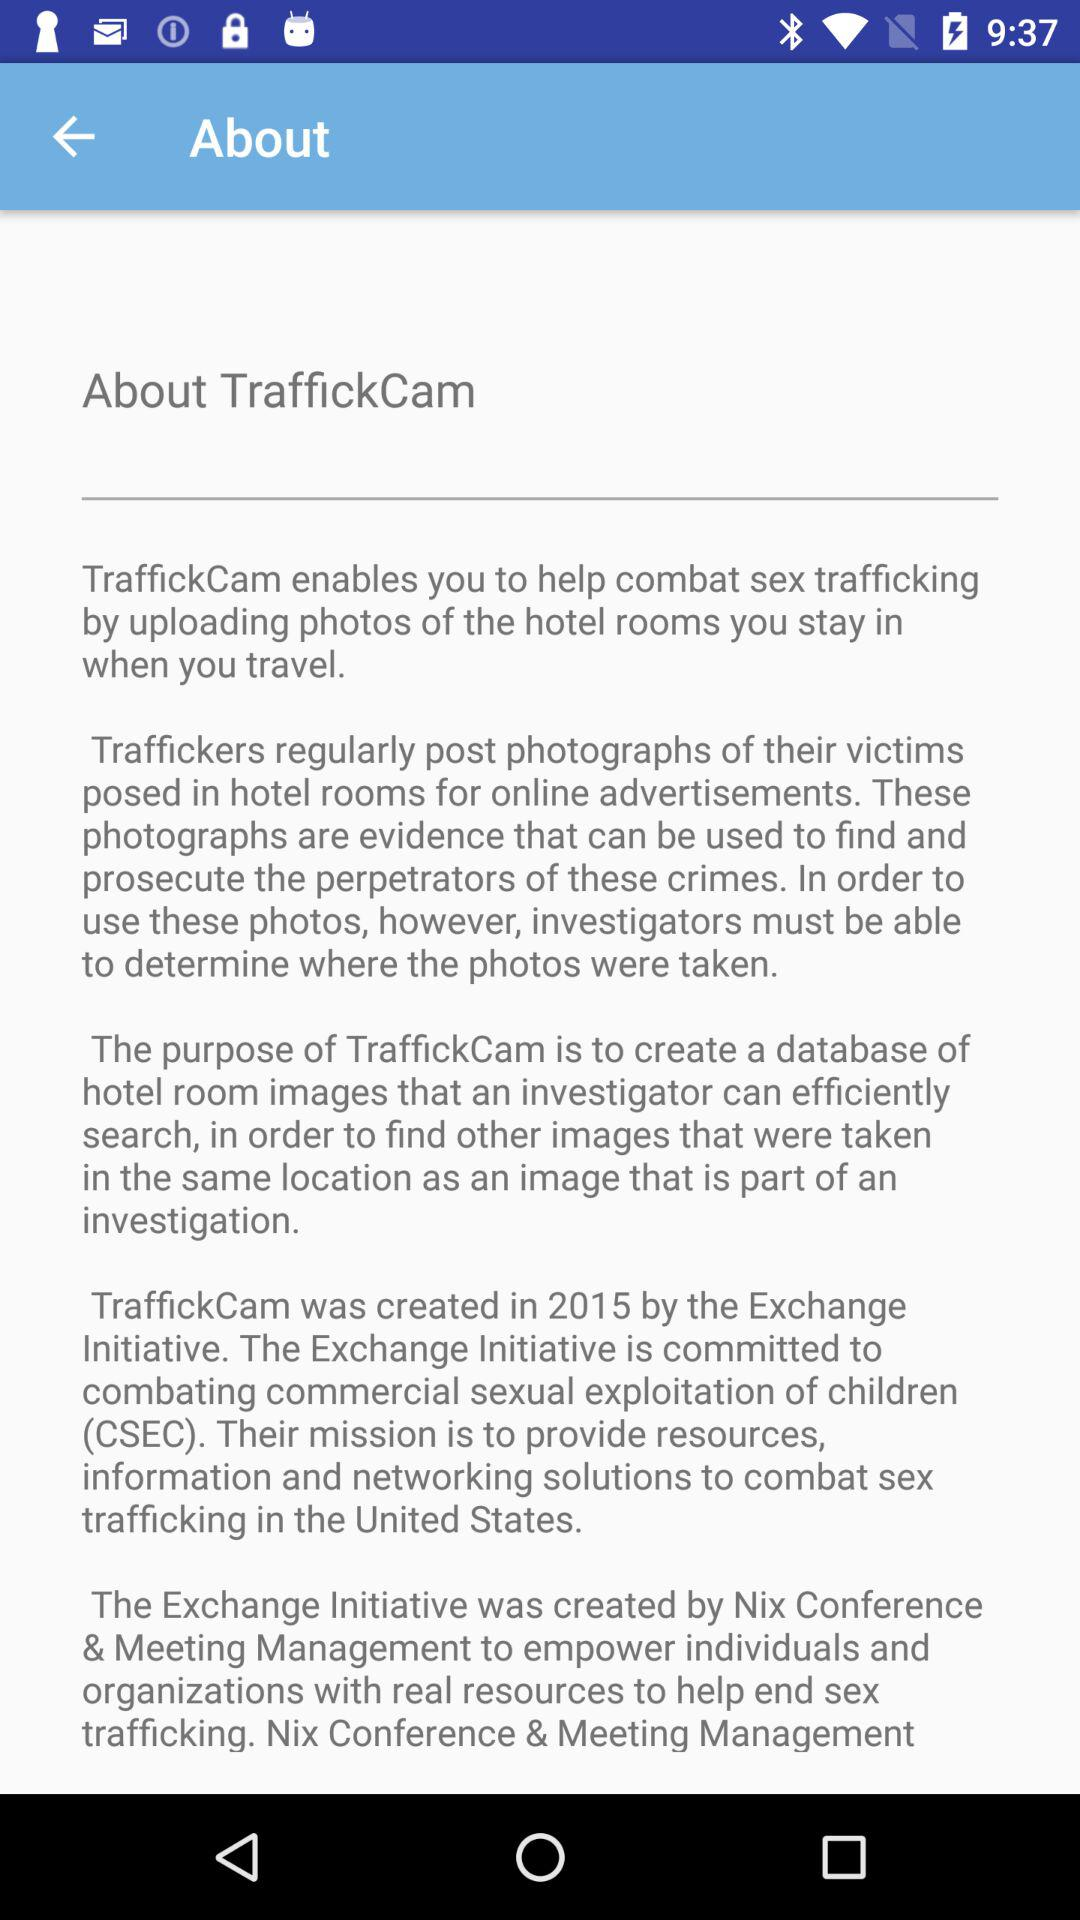When was the application "TraffickCam" created? The application "TraffickCam" was created in 2015. 